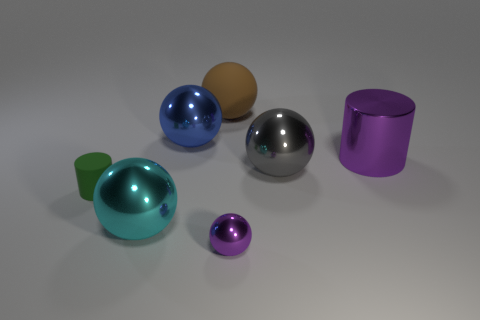Subtract 2 balls. How many balls are left? 3 Subtract all rubber balls. How many balls are left? 4 Subtract all yellow spheres. Subtract all cyan cylinders. How many spheres are left? 5 Add 2 green cylinders. How many objects exist? 9 Subtract all spheres. How many objects are left? 2 Subtract all big rubber spheres. Subtract all small red rubber cylinders. How many objects are left? 6 Add 2 brown rubber spheres. How many brown rubber spheres are left? 3 Add 5 tiny blue metallic objects. How many tiny blue metallic objects exist? 5 Subtract 0 yellow balls. How many objects are left? 7 